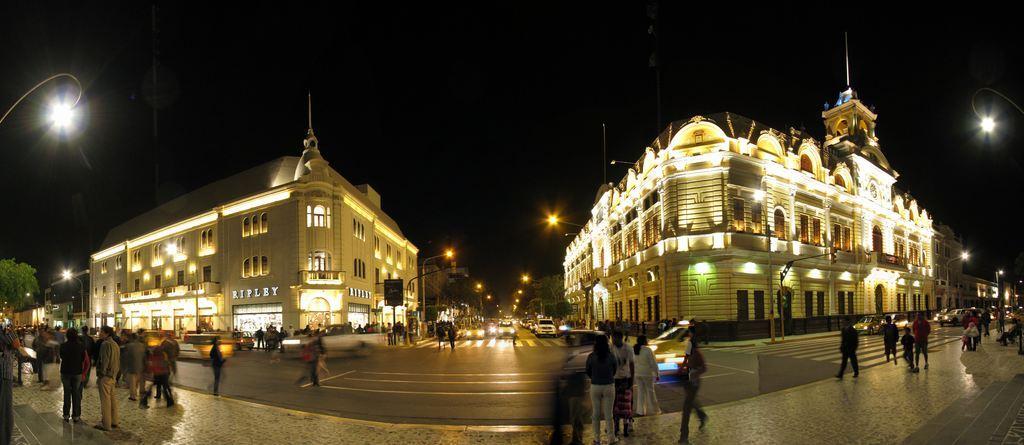In one or two sentences, can you explain what this image depicts? In this image we can see few buildings with lights, few street lights, few cars and people on the road and few people standing on the pavement, few trees and the sky in the background. 